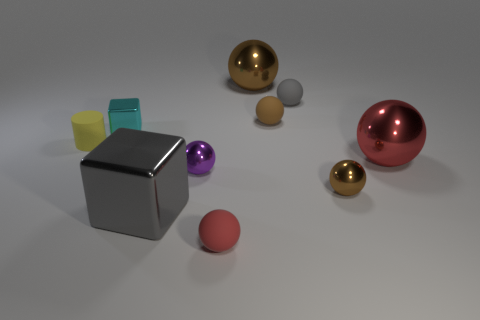What materials do the objects in the image appear to be made of? The objects seem to have various materials; the yellow cylinder and the cyan cube appear to be opaque and possibly made of a matte plastic. The large gray cube appears metallic with a reflective surface. The spheres, including the red, purple, gray, and gold ones, seem to have a glossy finish suggestive of a metal or glass-like material. 